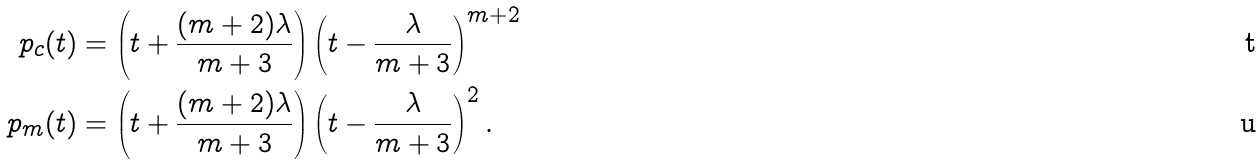Convert formula to latex. <formula><loc_0><loc_0><loc_500><loc_500>p _ { c } ( t ) & = \left ( t + \frac { ( m + 2 ) \lambda } { m + 3 } \right ) \left ( t - \frac { \lambda } { m + 3 } \right ) ^ { m + 2 } \\ p _ { m } ( t ) & = \left ( t + \frac { ( m + 2 ) \lambda } { m + 3 } \right ) \left ( t - \frac { \lambda } { m + 3 } \right ) ^ { 2 } .</formula> 